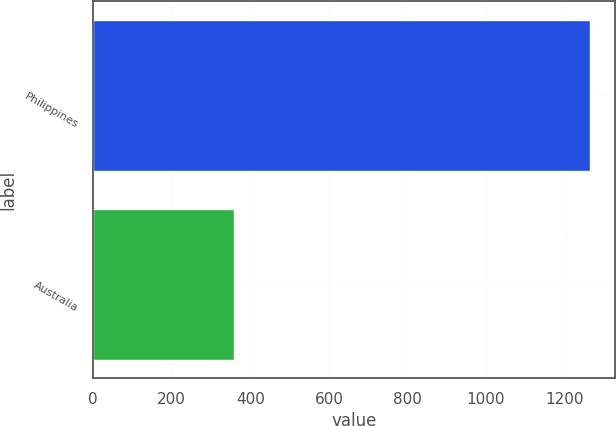Convert chart to OTSL. <chart><loc_0><loc_0><loc_500><loc_500><bar_chart><fcel>Philippines<fcel>Australia<nl><fcel>1265<fcel>359<nl></chart> 